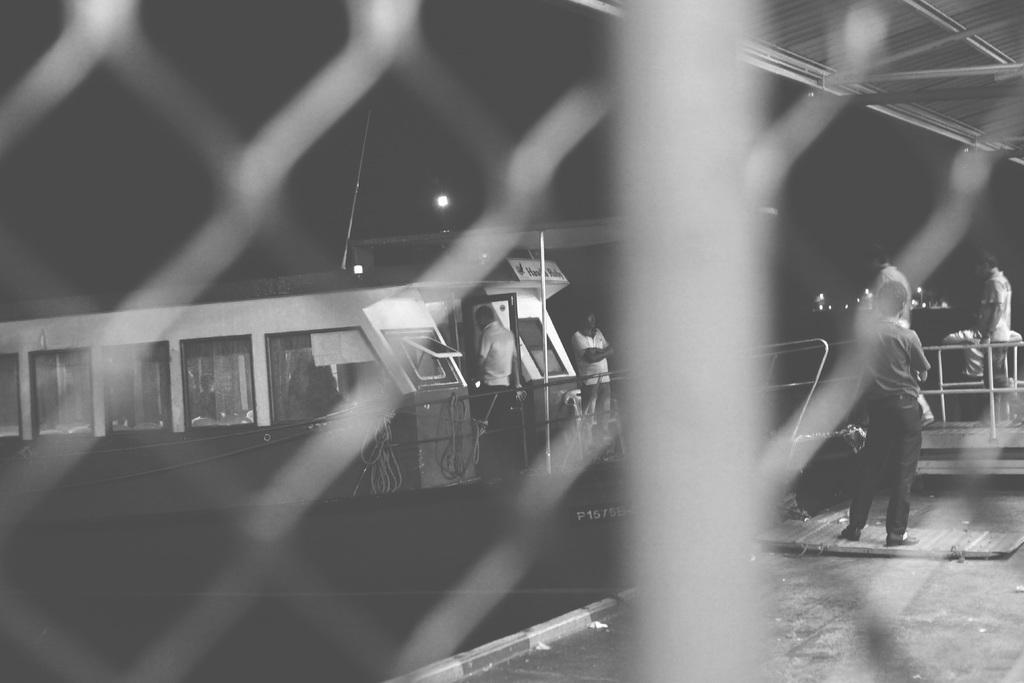Can you describe this image briefly? In this image we can see there is a fence, through the fence we can see there are people standing on the ship and there are a few people standing on the floor. At the top there are lights and shed. 